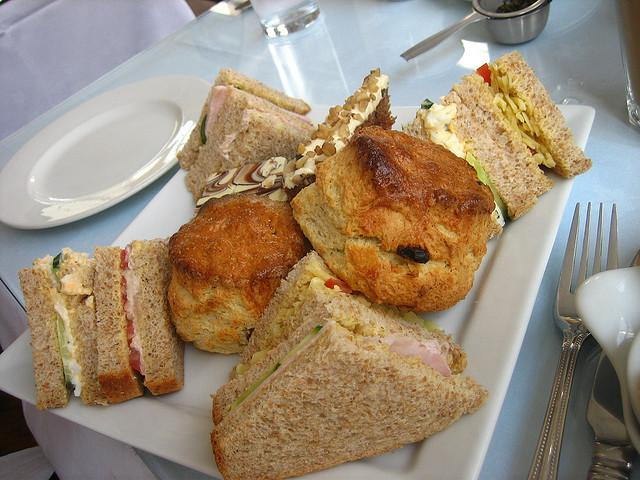What time is conducive to take the meal above? Please explain your reasoning. morning. There are scones and sandwiches which are typically eaten at lunch time. 